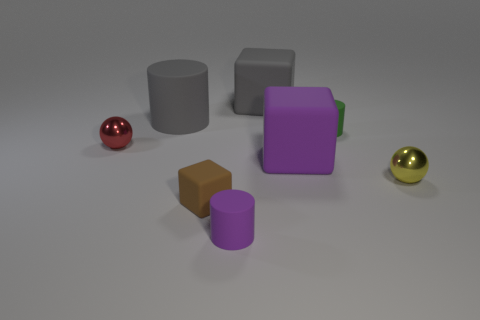Subtract all tiny cylinders. How many cylinders are left? 1 Subtract 1 cubes. How many cubes are left? 2 Add 1 cyan objects. How many objects exist? 9 Subtract all gray cubes. How many cubes are left? 2 Subtract all cubes. How many objects are left? 5 Subtract all brown cylinders. Subtract all blue blocks. How many cylinders are left? 3 Subtract 1 brown blocks. How many objects are left? 7 Subtract all cubes. Subtract all purple cylinders. How many objects are left? 4 Add 6 purple cylinders. How many purple cylinders are left? 7 Add 7 yellow metallic balls. How many yellow metallic balls exist? 8 